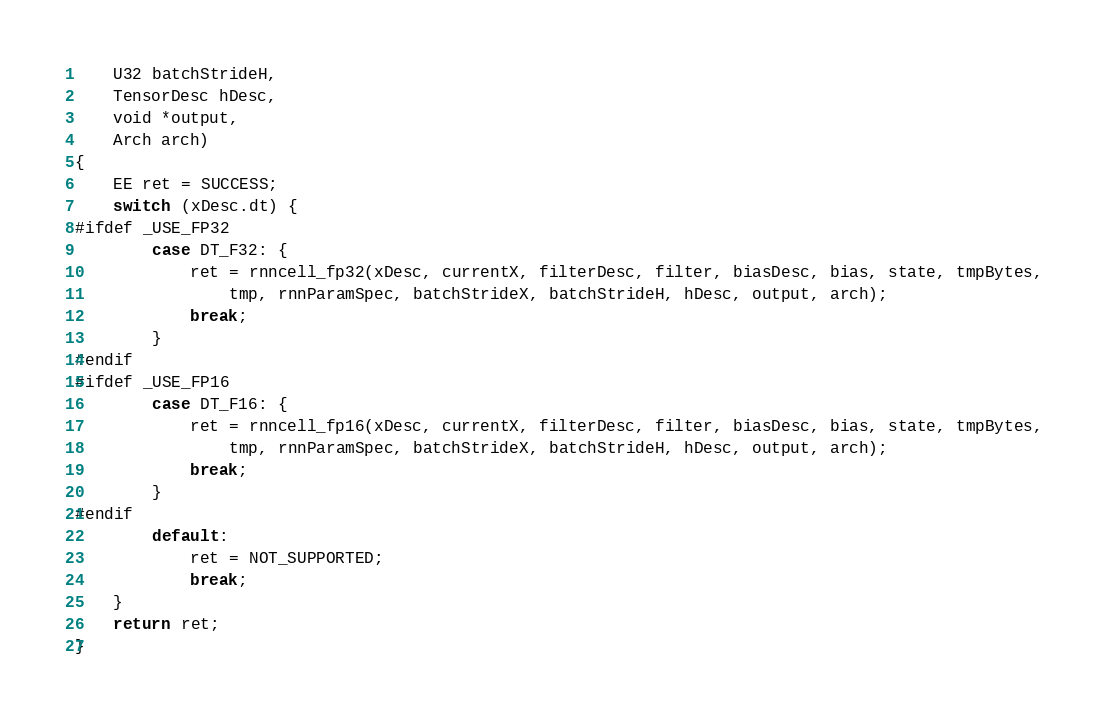Convert code to text. <code><loc_0><loc_0><loc_500><loc_500><_C++_>    U32 batchStrideH,
    TensorDesc hDesc,
    void *output,
    Arch arch)
{
    EE ret = SUCCESS;
    switch (xDesc.dt) {
#ifdef _USE_FP32
        case DT_F32: {
            ret = rnncell_fp32(xDesc, currentX, filterDesc, filter, biasDesc, bias, state, tmpBytes,
                tmp, rnnParamSpec, batchStrideX, batchStrideH, hDesc, output, arch);
            break;
        }
#endif
#ifdef _USE_FP16
        case DT_F16: {
            ret = rnncell_fp16(xDesc, currentX, filterDesc, filter, biasDesc, bias, state, tmpBytes,
                tmp, rnnParamSpec, batchStrideX, batchStrideH, hDesc, output, arch);
            break;
        }
#endif
        default:
            ret = NOT_SUPPORTED;
            break;
    }
    return ret;
}
</code> 